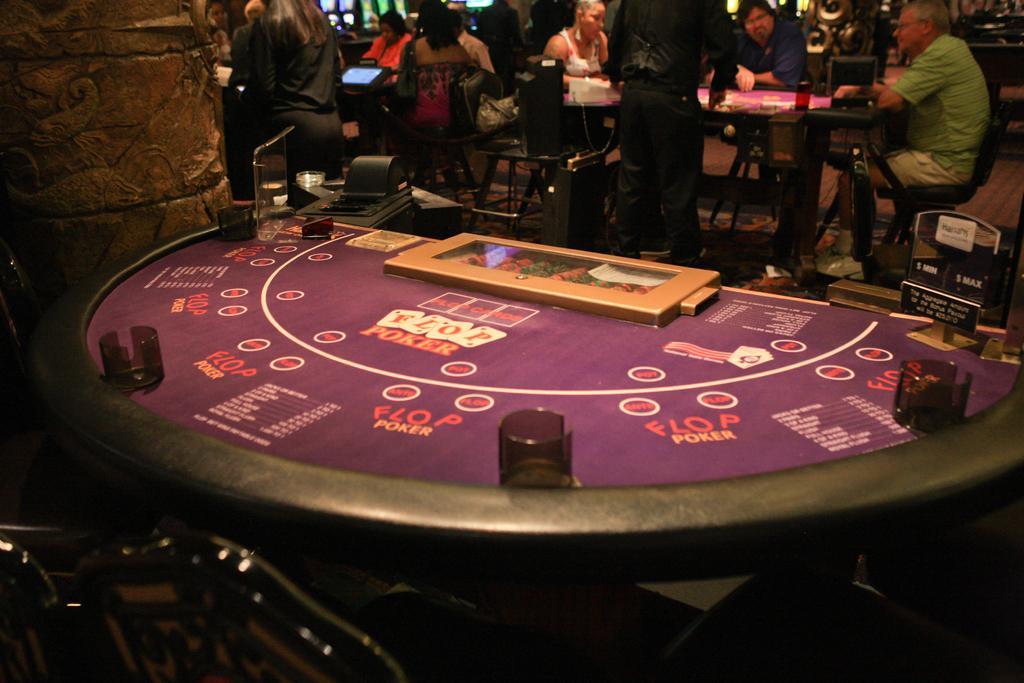Could you give a brief overview of what you see in this image? In this image, we can see a table. On top of that we can see few objects. Top of the image, there are few people, chairs, tables, carvings and few objects. 